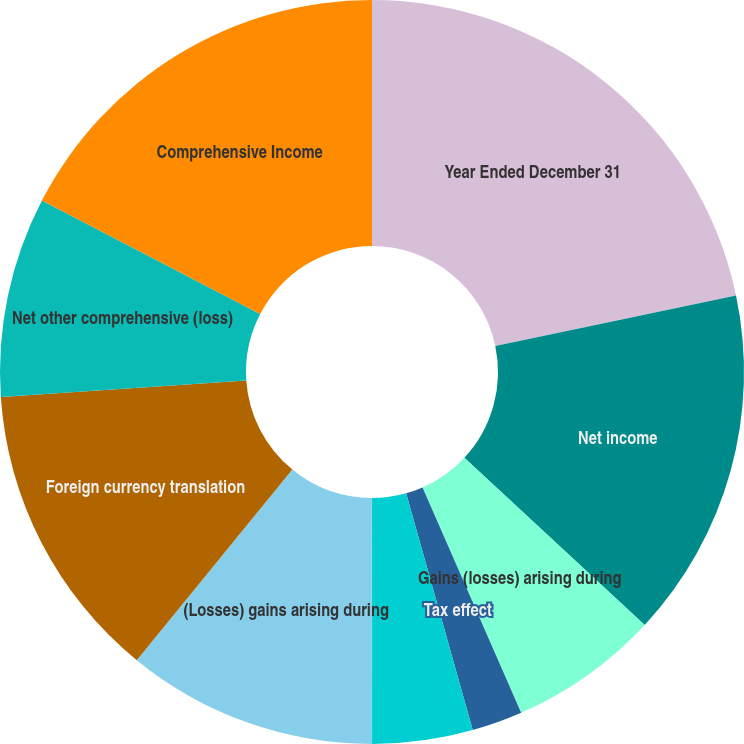Convert chart. <chart><loc_0><loc_0><loc_500><loc_500><pie_chart><fcel>Year Ended December 31<fcel>Net income<fcel>Gains (losses) arising during<fcel>Tax effect<fcel>Reclassification adjustment<fcel>Net holding gain (loss)<fcel>(Losses) gains arising during<fcel>Foreign currency translation<fcel>Net other comprehensive (loss)<fcel>Comprehensive Income<nl><fcel>21.7%<fcel>15.2%<fcel>6.53%<fcel>2.2%<fcel>4.36%<fcel>0.03%<fcel>10.87%<fcel>13.03%<fcel>8.7%<fcel>17.37%<nl></chart> 